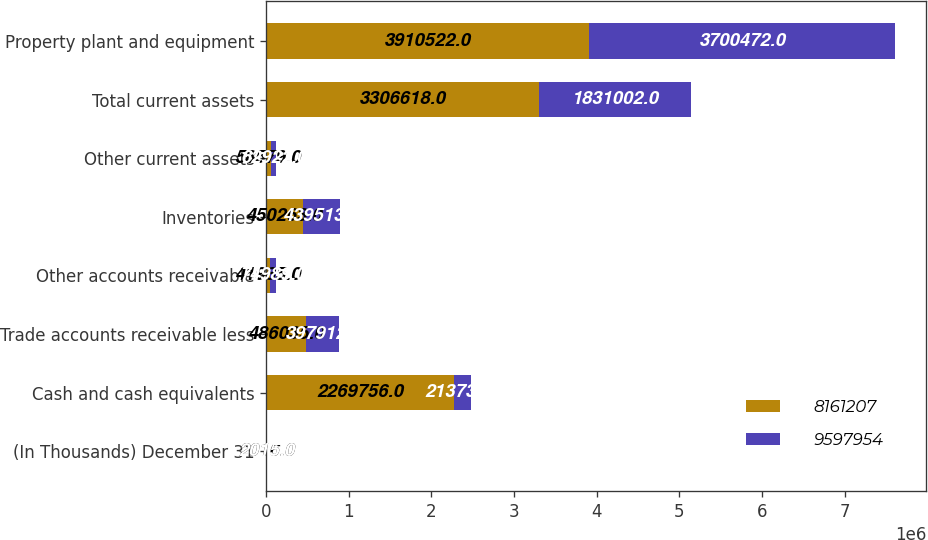Convert chart. <chart><loc_0><loc_0><loc_500><loc_500><stacked_bar_chart><ecel><fcel>(In Thousands) December 31<fcel>Cash and cash equivalents<fcel>Trade accounts receivable less<fcel>Other accounts receivable<fcel>Inventories<fcel>Other current assets<fcel>Total current assets<fcel>Property plant and equipment<nl><fcel>8.16121e+06<fcel>2016<fcel>2.26976e+06<fcel>486035<fcel>41985<fcel>450263<fcel>58579<fcel>3.30662e+06<fcel>3.91052e+06<nl><fcel>9.59795e+06<fcel>2015<fcel>213734<fcel>397912<fcel>74989<fcel>439513<fcel>62922<fcel>1.831e+06<fcel>3.70047e+06<nl></chart> 